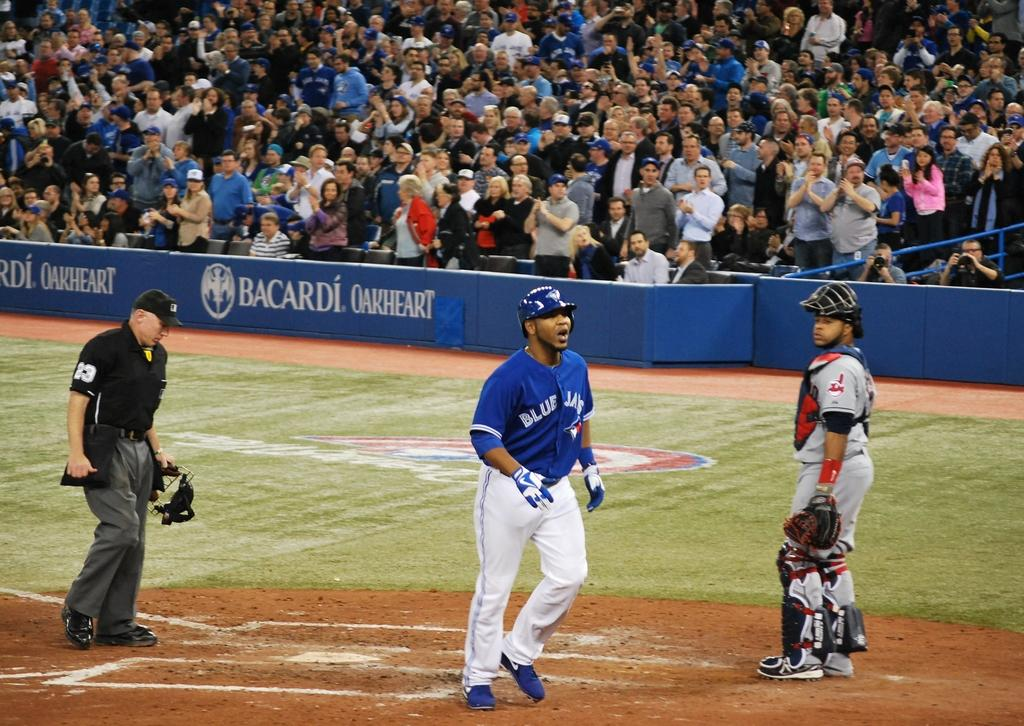<image>
Describe the image concisely. Players on a field that is sponsored by Bacardi. 